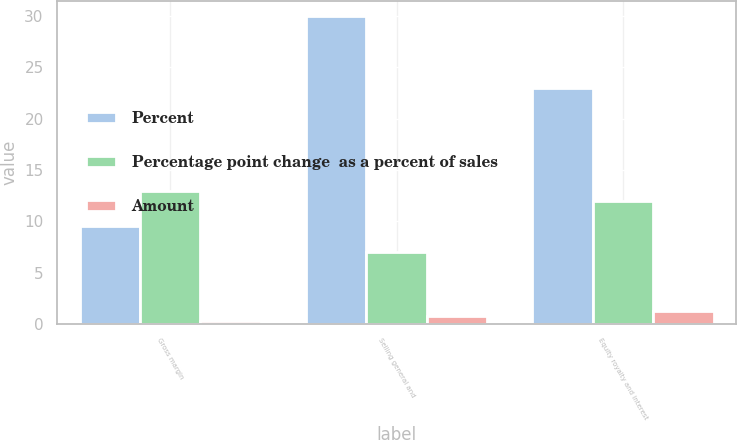<chart> <loc_0><loc_0><loc_500><loc_500><stacked_bar_chart><ecel><fcel>Gross margin<fcel>Selling general and<fcel>Equity royalty and interest<nl><fcel>Percent<fcel>9.5<fcel>30<fcel>23<nl><fcel>Percentage point change  as a percent of sales<fcel>13<fcel>7<fcel>12<nl><fcel>Amount<fcel>0.3<fcel>0.8<fcel>1.3<nl></chart> 